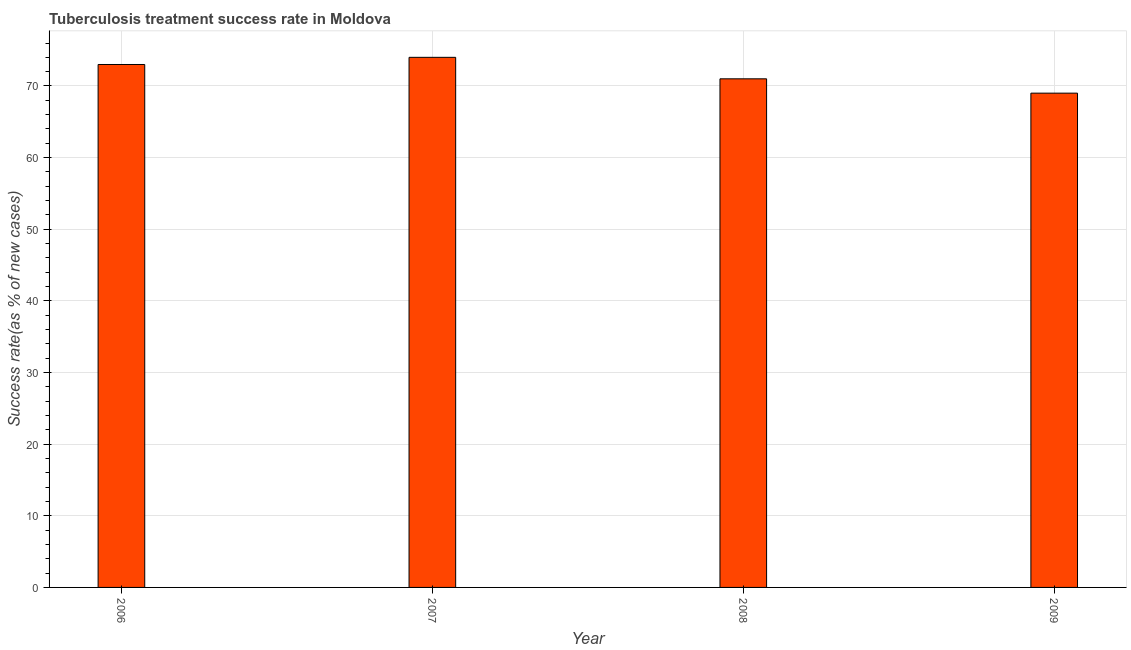Does the graph contain any zero values?
Offer a terse response. No. What is the title of the graph?
Your answer should be compact. Tuberculosis treatment success rate in Moldova. What is the label or title of the X-axis?
Give a very brief answer. Year. What is the label or title of the Y-axis?
Ensure brevity in your answer.  Success rate(as % of new cases). What is the tuberculosis treatment success rate in 2009?
Your answer should be compact. 69. In which year was the tuberculosis treatment success rate minimum?
Offer a very short reply. 2009. What is the sum of the tuberculosis treatment success rate?
Keep it short and to the point. 287. What is the average tuberculosis treatment success rate per year?
Offer a terse response. 71. What is the median tuberculosis treatment success rate?
Offer a very short reply. 72. In how many years, is the tuberculosis treatment success rate greater than 12 %?
Ensure brevity in your answer.  4. Is the difference between the tuberculosis treatment success rate in 2006 and 2008 greater than the difference between any two years?
Provide a short and direct response. No. Is the sum of the tuberculosis treatment success rate in 2006 and 2009 greater than the maximum tuberculosis treatment success rate across all years?
Offer a terse response. Yes. What is the difference between the highest and the lowest tuberculosis treatment success rate?
Offer a very short reply. 5. What is the difference between two consecutive major ticks on the Y-axis?
Your answer should be very brief. 10. What is the Success rate(as % of new cases) in 2009?
Offer a terse response. 69. What is the difference between the Success rate(as % of new cases) in 2006 and 2007?
Ensure brevity in your answer.  -1. What is the difference between the Success rate(as % of new cases) in 2006 and 2008?
Provide a succinct answer. 2. What is the difference between the Success rate(as % of new cases) in 2006 and 2009?
Offer a very short reply. 4. What is the difference between the Success rate(as % of new cases) in 2007 and 2009?
Provide a succinct answer. 5. What is the difference between the Success rate(as % of new cases) in 2008 and 2009?
Provide a succinct answer. 2. What is the ratio of the Success rate(as % of new cases) in 2006 to that in 2007?
Keep it short and to the point. 0.99. What is the ratio of the Success rate(as % of new cases) in 2006 to that in 2008?
Your answer should be very brief. 1.03. What is the ratio of the Success rate(as % of new cases) in 2006 to that in 2009?
Your answer should be compact. 1.06. What is the ratio of the Success rate(as % of new cases) in 2007 to that in 2008?
Provide a short and direct response. 1.04. What is the ratio of the Success rate(as % of new cases) in 2007 to that in 2009?
Give a very brief answer. 1.07. What is the ratio of the Success rate(as % of new cases) in 2008 to that in 2009?
Provide a succinct answer. 1.03. 